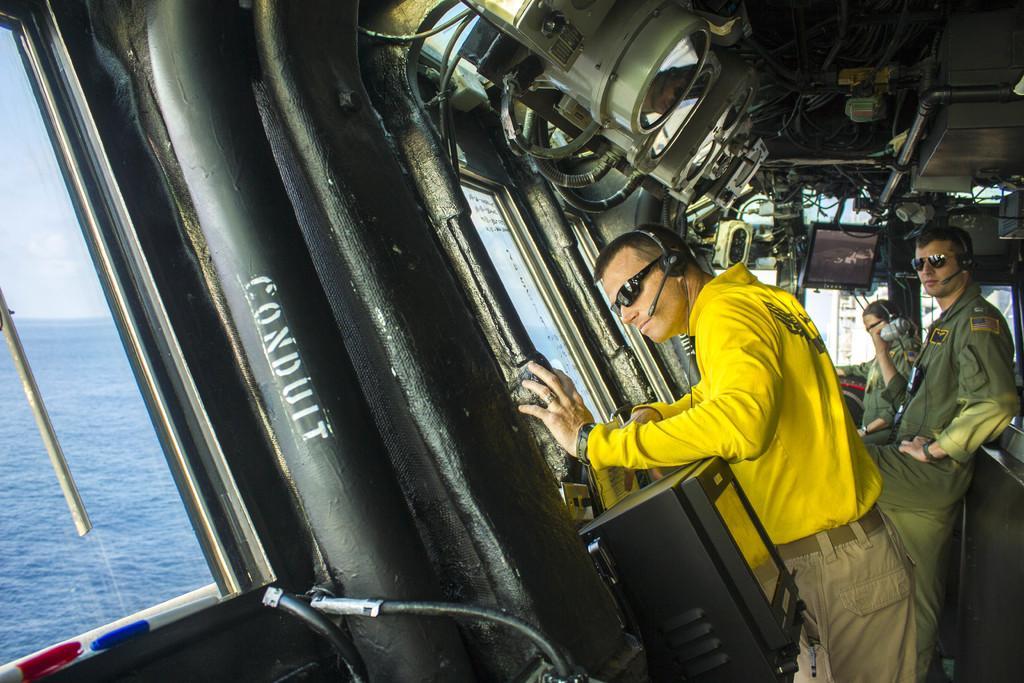How would you summarize this image in a sentence or two? In this image we can see a ship on the water, in the ship we can see three persons standing and wearing head phones, in the background we can see the sky with clouds. 